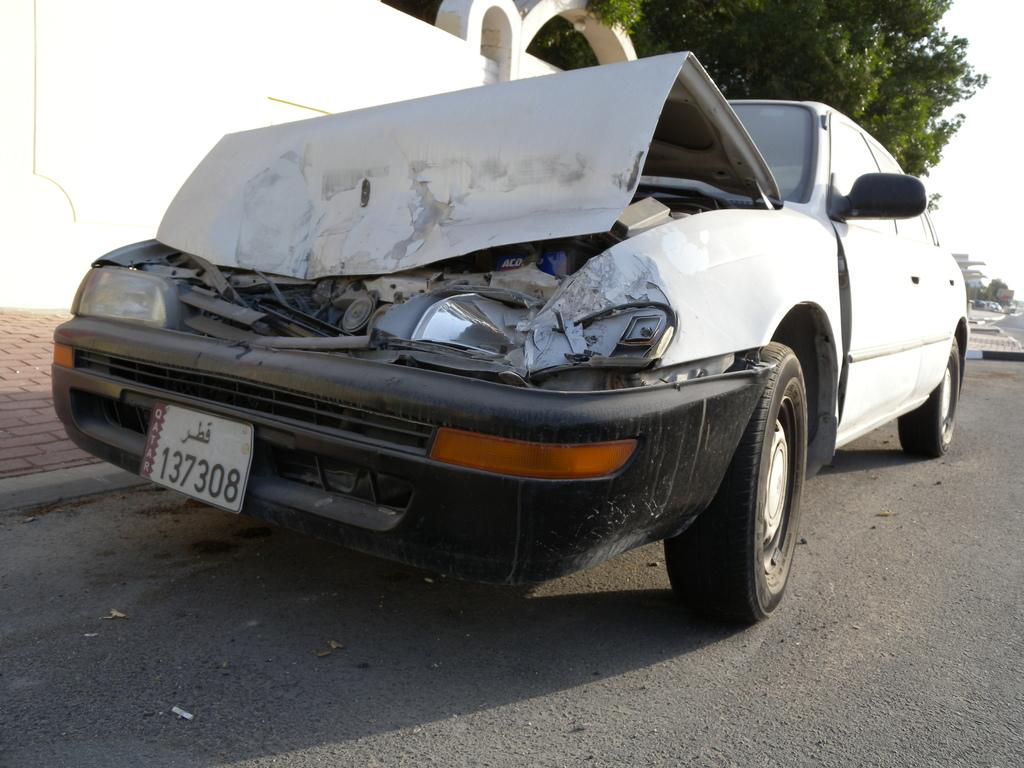<image>
Relay a brief, clear account of the picture shown. a license plate with 137308 on the front 